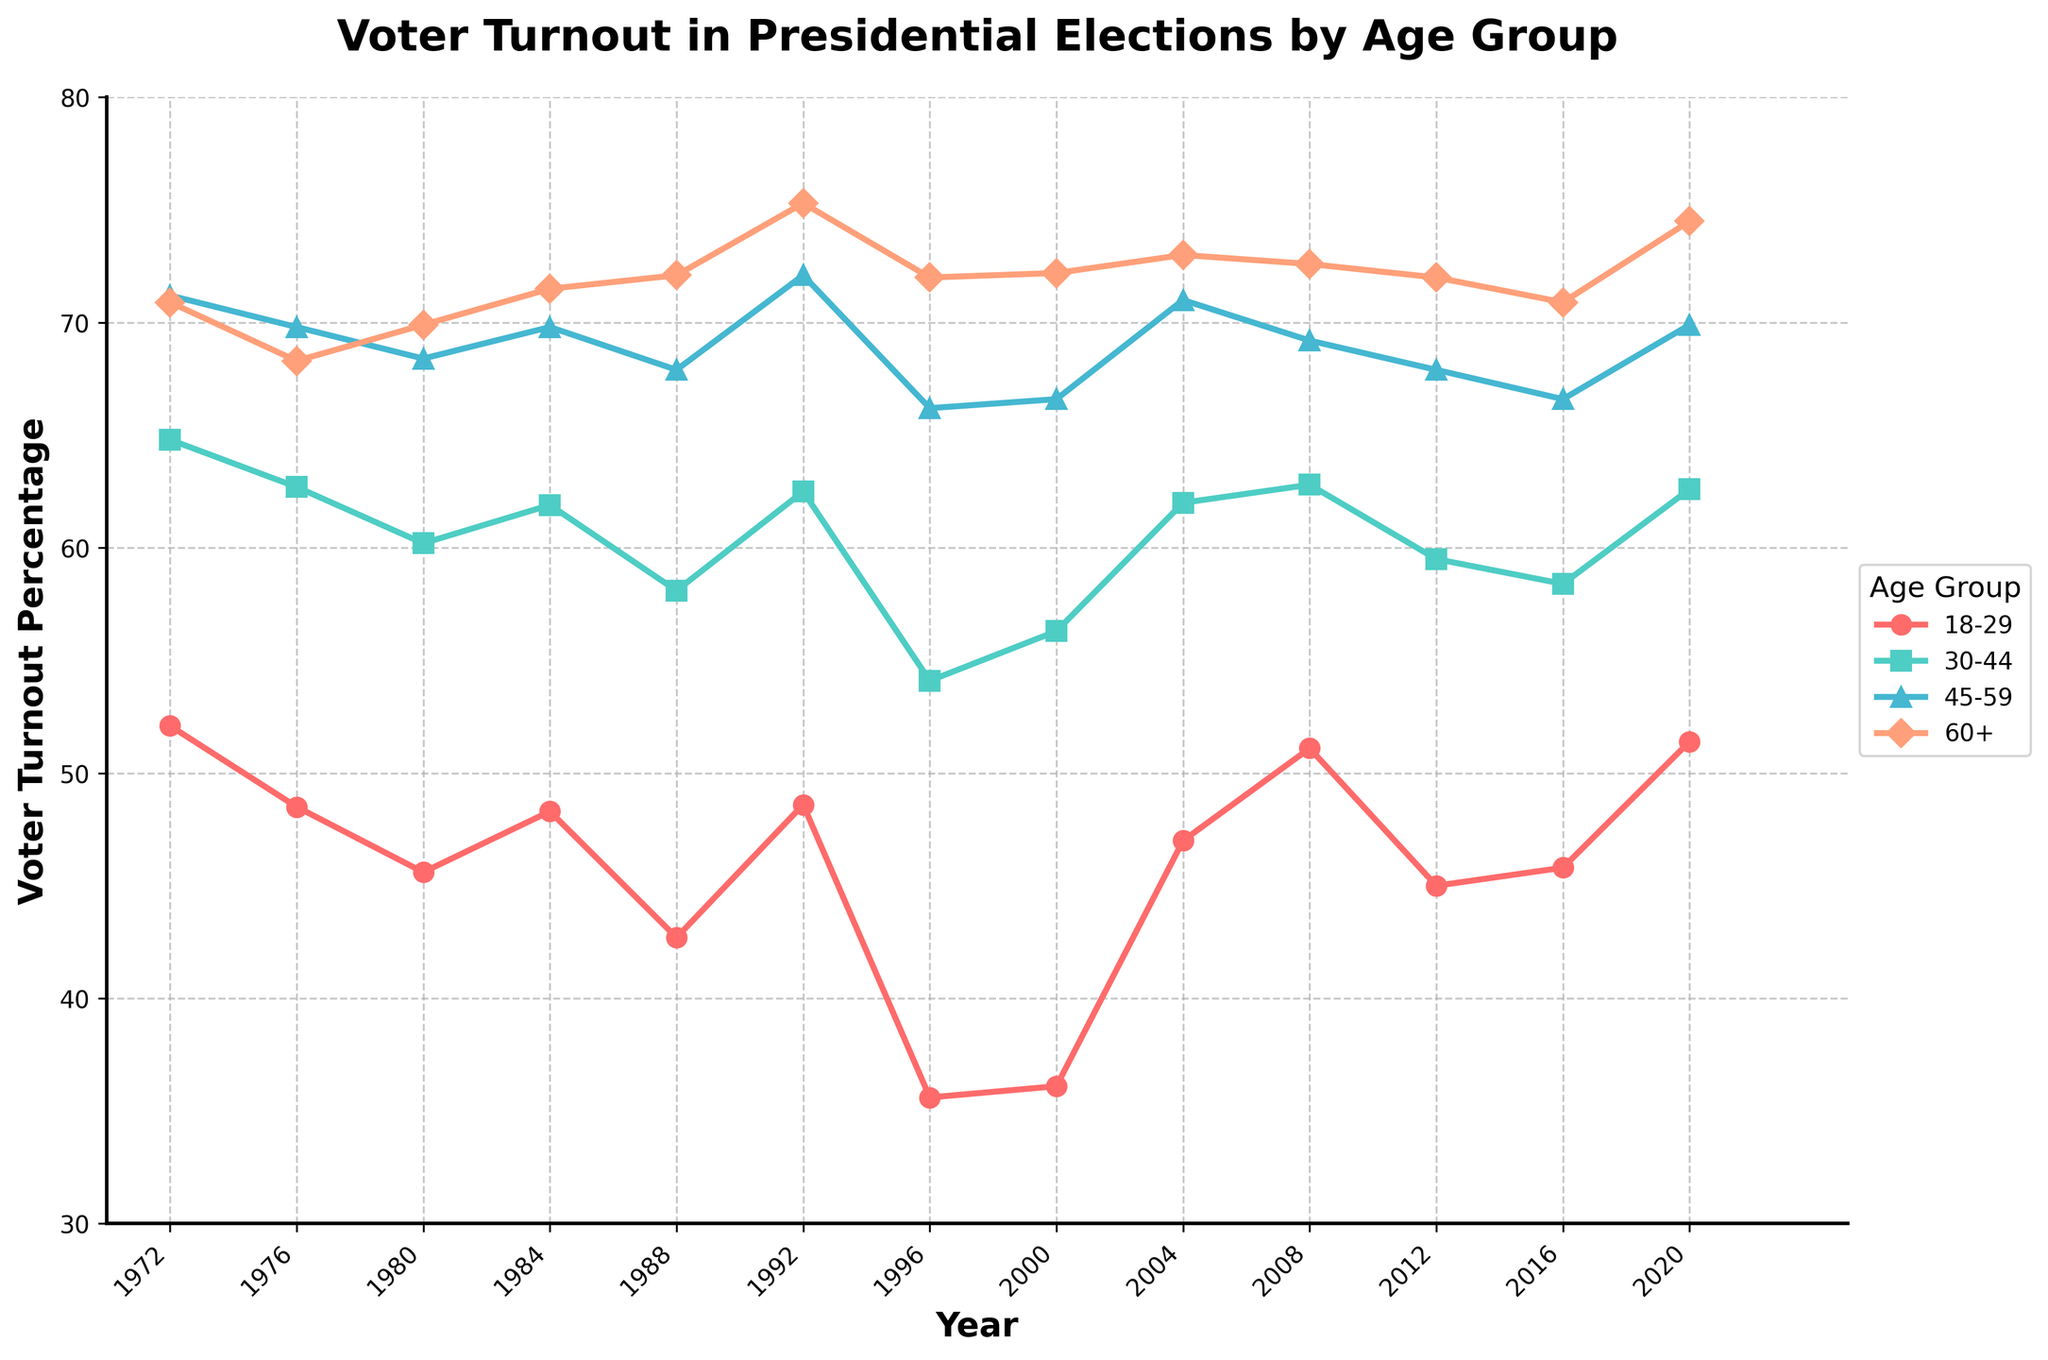What's the overall trend of voter turnout for the 18-29 age group from 1972 to 2020? The trend shows fluctuations, with a decrease from 52.1% in 1972 to 35.6% in 1996, followed by a general increase to 51.4% in 2020.
Answer: Fluctuating with a general increase after 1996 Which age group consistently has the highest voter turnout over the years? By visually comparing the lines, the 60+ age group consistently shows the highest voter turnout across all election years.
Answer: 60+ In which year did the voter turnout percentage for the 30-44 age group see its lowest point, and what was the percentage? Observing the line for the 30-44 age group, the lowest point is in 1996 with a voter turnout percentage of 54.1%.
Answer: 1996 and 54.1% How did the voter turnout for the 45-59 age group change between 1972 and 2020? The voter turnout for the 45-59 age group decreased slightly from 71.2% in 1972 to 69.9% in 2020, despite some fluctuations in between.
Answer: Decreased from 71.2% to 69.9% Compare the voter turnout change between the 18-29 and 60+ age groups from 2000 to 2020. The 18-29 age group increased from 36.1% to 51.4%, while the 60+ age group increased from 72.2% to 74.5%. Both age groups saw an increase, with the 18-29 age group having a larger relative increase.
Answer: Both increased, 18-29 more substantially Which age group experienced the most significant drop in voter turnout from 1972 to 1976? By comparing the drops between 1972 and 1976 for each age group, the 18-29 group experienced the most significant drop from 52.1% to 48.5%, a decrease of 3.6 percentage points.
Answer: 18-29 What is the average voter turnout for the 60+ age group over the 50 years? Calculate the average by summing the percentages for the 60+ age group across all years and then dividing by the number of years: (70.9+68.3+69.9+71.5+72.1+75.3+72.0+72.2+73.0+72.6+72.0+70.9+74.5)/13 ≈ 71.8%.
Answer: 71.8% Which age group saw a dip in voter turnout during the 1996 election, and how significant was it compared to the previous election year? The 18-29 age group had the most pronounced dip in 1996, from 48.6% in 1992 to 35.6%, a drop of 13 percentage points.
Answer: 18-29, dropped by 13% During which election years did the 60+ age group have a voter turnout above 72%? Observing the figure, the 60+ age group had voter turnout above 72% in the years 1988, 1992, 2000, 2004, 2008, and 2020.
Answer: 1988, 1992, 2000, 2004, 2008, 2020 